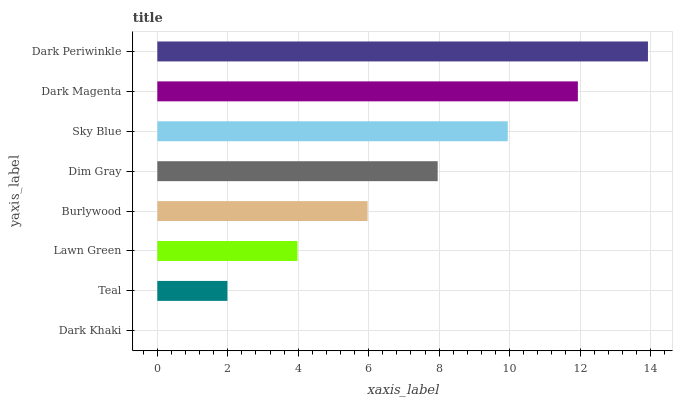Is Dark Khaki the minimum?
Answer yes or no. Yes. Is Dark Periwinkle the maximum?
Answer yes or no. Yes. Is Teal the minimum?
Answer yes or no. No. Is Teal the maximum?
Answer yes or no. No. Is Teal greater than Dark Khaki?
Answer yes or no. Yes. Is Dark Khaki less than Teal?
Answer yes or no. Yes. Is Dark Khaki greater than Teal?
Answer yes or no. No. Is Teal less than Dark Khaki?
Answer yes or no. No. Is Dim Gray the high median?
Answer yes or no. Yes. Is Burlywood the low median?
Answer yes or no. Yes. Is Teal the high median?
Answer yes or no. No. Is Dim Gray the low median?
Answer yes or no. No. 